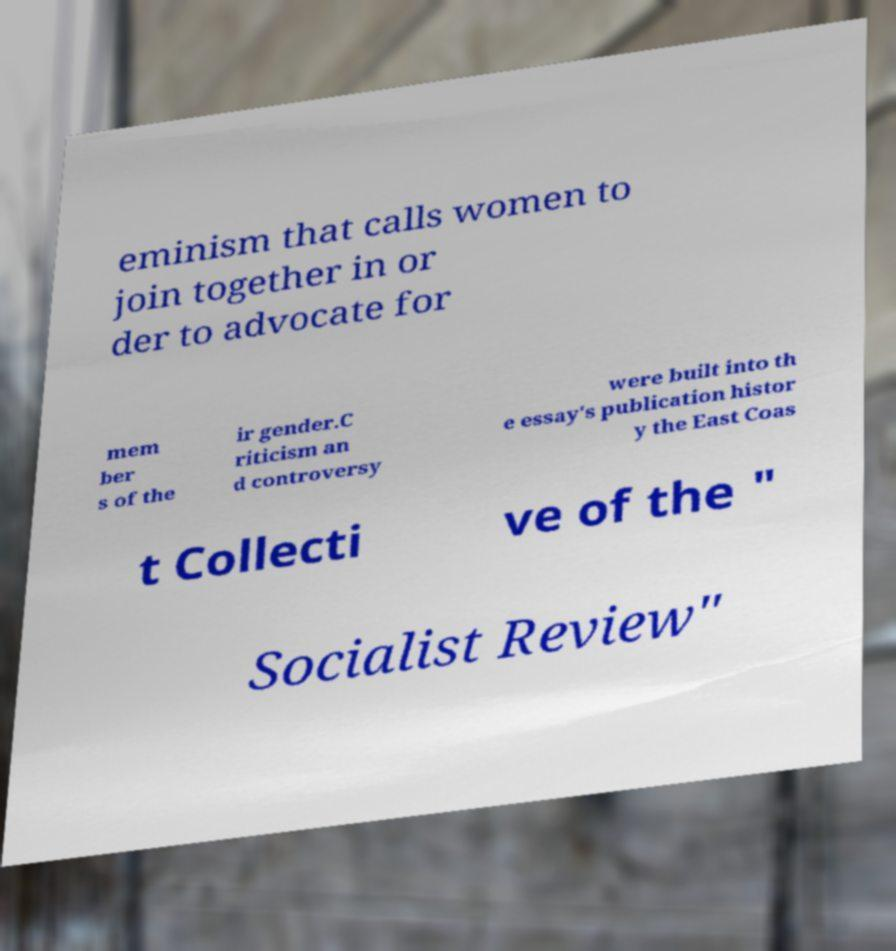There's text embedded in this image that I need extracted. Can you transcribe it verbatim? eminism that calls women to join together in or der to advocate for mem ber s of the ir gender.C riticism an d controversy were built into th e essay's publication histor y the East Coas t Collecti ve of the " Socialist Review" 